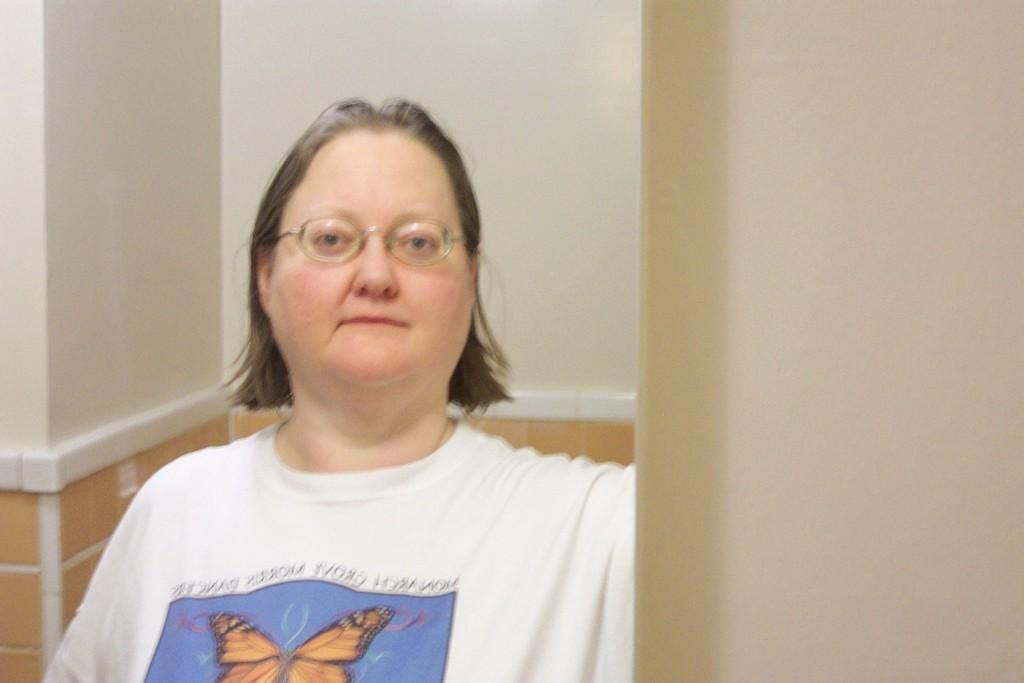Who is the main subject in the picture? There is a woman in the picture. What is the woman wearing in the image? The woman is wearing a white t-shirt. Are there any accessories visible on the woman? Yes, the woman is wearing spectacles. What can be seen in the background of the picture? There is a wall in the background of the picture. What type of oven is the woman using to start cooking in the image? There is no oven or cooking activity present in the image. 